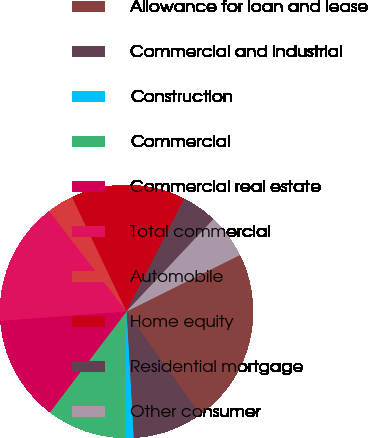<chart> <loc_0><loc_0><loc_500><loc_500><pie_chart><fcel>Allowance for loan and lease<fcel>Commercial and industrial<fcel>Construction<fcel>Commercial<fcel>Commercial real estate<fcel>Total commercial<fcel>Automobile<fcel>Home equity<fcel>Residential mortgage<fcel>Other consumer<nl><fcel>22.47%<fcel>8.99%<fcel>1.13%<fcel>10.11%<fcel>13.48%<fcel>15.73%<fcel>3.37%<fcel>14.6%<fcel>4.5%<fcel>5.62%<nl></chart> 